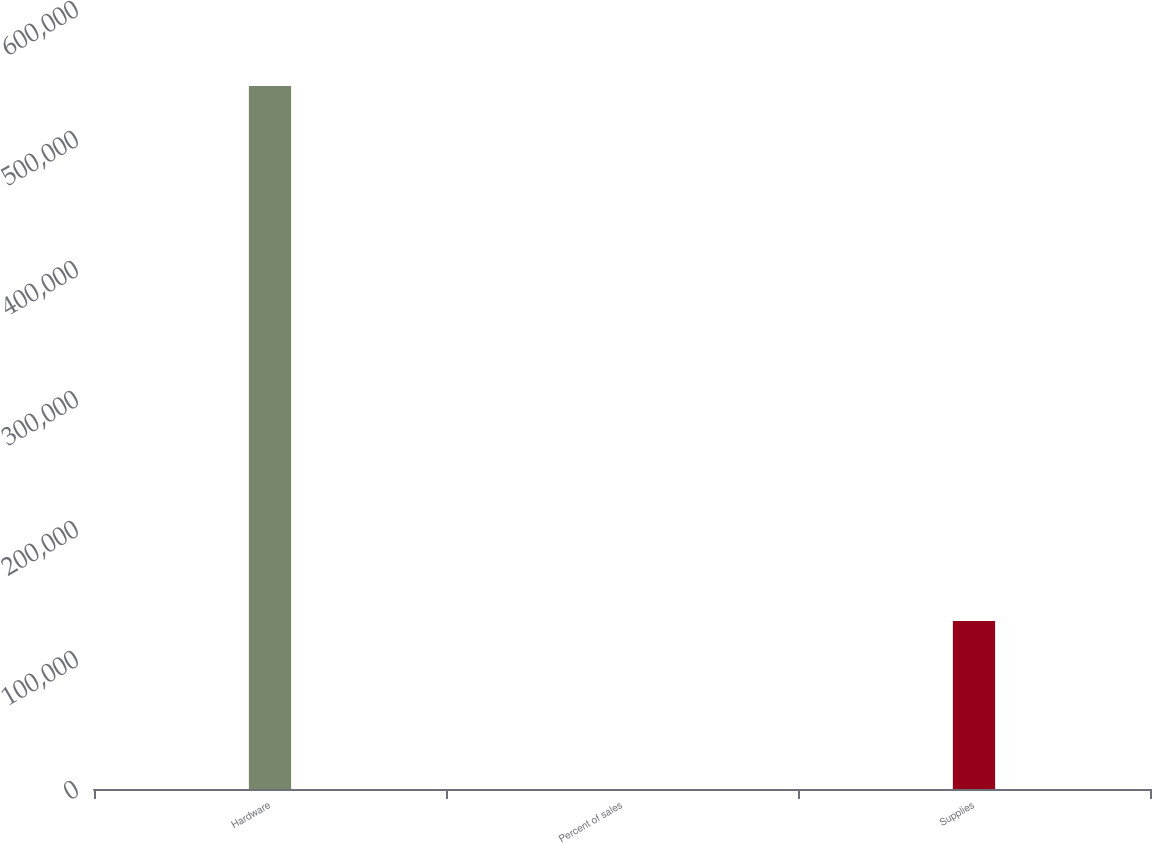<chart> <loc_0><loc_0><loc_500><loc_500><bar_chart><fcel>Hardware<fcel>Percent of sales<fcel>Supplies<nl><fcel>540679<fcel>77<fcel>129183<nl></chart> 